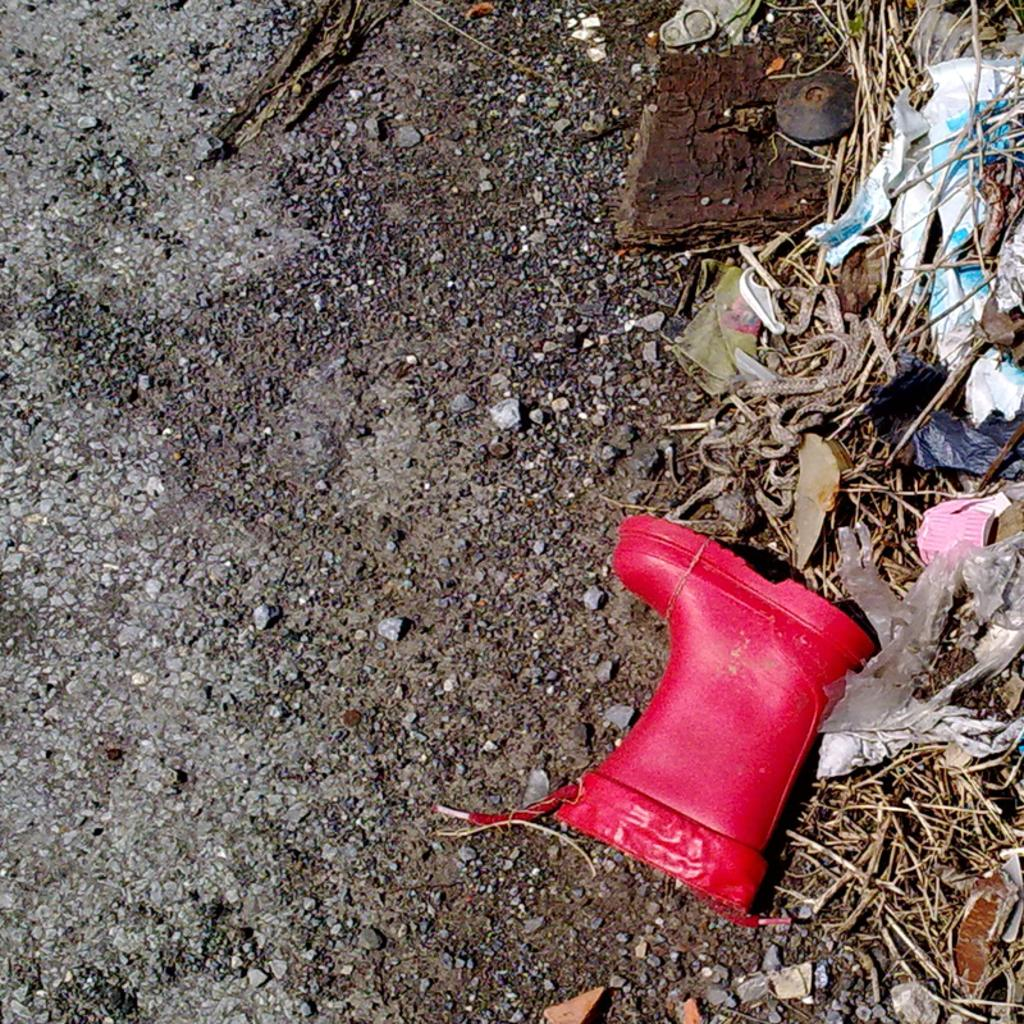What is on the road in the image? There is a shoe on the road. Are there any other objects on the road besides the shoe? Yes, there are other objects on the road. Where is the nest of gold coins located in the image? There is no nest of gold coins present in the image. 